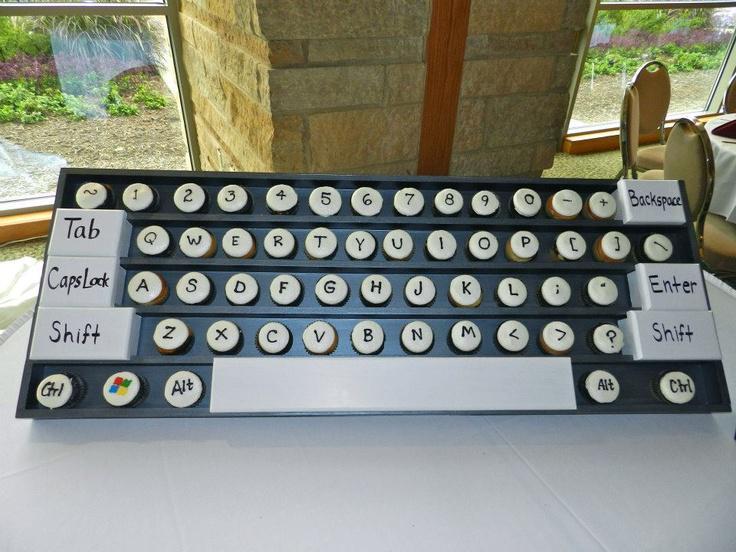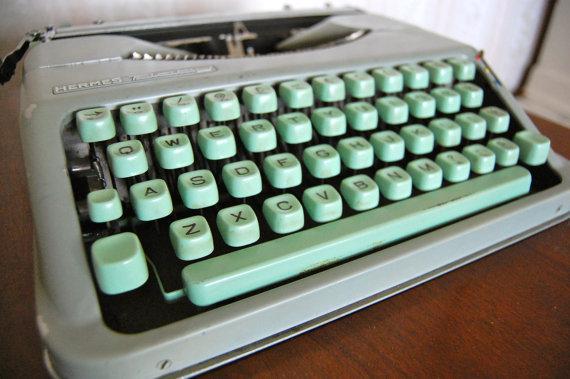The first image is the image on the left, the second image is the image on the right. Examine the images to the left and right. Is the description "Several keyboards appear in at least one of the images." accurate? Answer yes or no. No. The first image is the image on the left, the second image is the image on the right. For the images shown, is this caption "In one image, an old-fashioned typewriter is shown with at least some of the keys colored." true? Answer yes or no. Yes. 